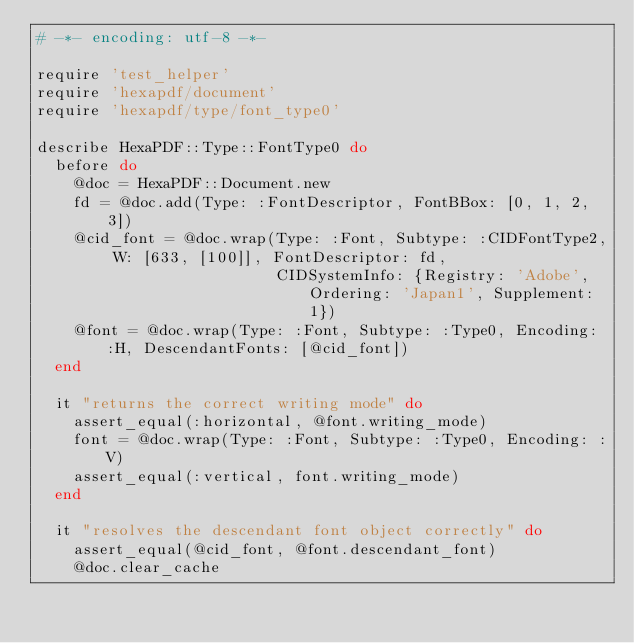Convert code to text. <code><loc_0><loc_0><loc_500><loc_500><_Ruby_># -*- encoding: utf-8 -*-

require 'test_helper'
require 'hexapdf/document'
require 'hexapdf/type/font_type0'

describe HexaPDF::Type::FontType0 do
  before do
    @doc = HexaPDF::Document.new
    fd = @doc.add(Type: :FontDescriptor, FontBBox: [0, 1, 2, 3])
    @cid_font = @doc.wrap(Type: :Font, Subtype: :CIDFontType2, W: [633, [100]], FontDescriptor: fd,
                          CIDSystemInfo: {Registry: 'Adobe', Ordering: 'Japan1', Supplement: 1})
    @font = @doc.wrap(Type: :Font, Subtype: :Type0, Encoding: :H, DescendantFonts: [@cid_font])
  end

  it "returns the correct writing mode" do
    assert_equal(:horizontal, @font.writing_mode)
    font = @doc.wrap(Type: :Font, Subtype: :Type0, Encoding: :V)
    assert_equal(:vertical, font.writing_mode)
  end

  it "resolves the descendant font object correctly" do
    assert_equal(@cid_font, @font.descendant_font)
    @doc.clear_cache</code> 